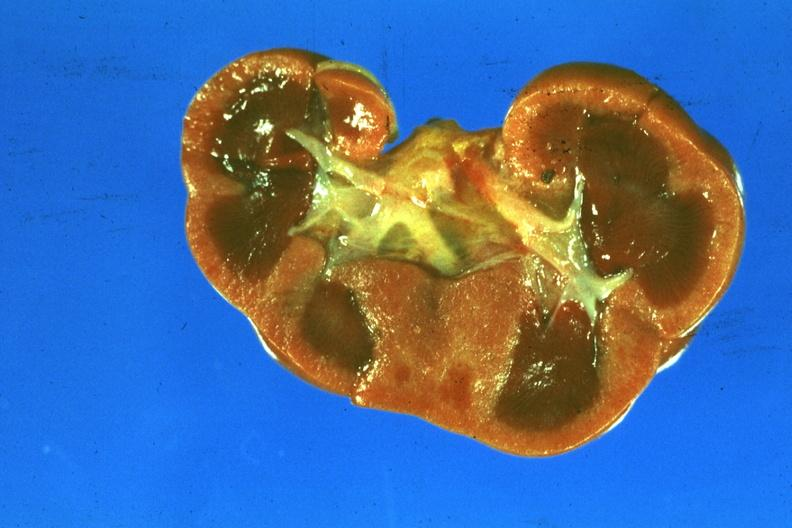s gram present?
Answer the question using a single word or phrase. No 